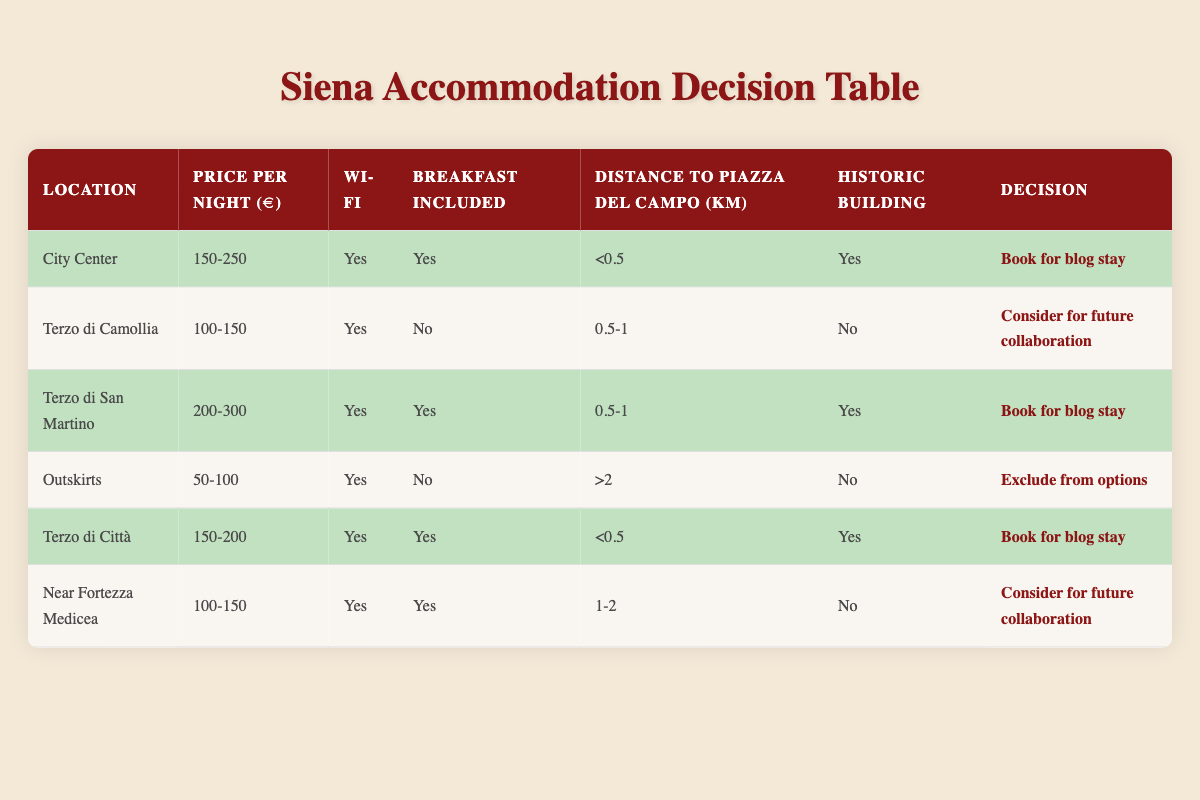What is the price range for accommodations in the City Center? The table shows the price per night for accommodations in the City Center is listed as 150-250 euros.
Answer: 150-250 euros How many accommodation options include breakfast? In the table, the options that include breakfast are the City Center, Terzo di San Martino, Terzo di Città, and Near Fortezza Medicea. There are 4 such accommodations.
Answer: 4 Which location has the highest price per night? The location with the highest price per night is Terzo di San Martino, with a price range of 200-300 euros.
Answer: Terzo di San Martino Is there any accommodation option that is both historic and located at a distance greater than 1 km from Piazza del Campo? The table lists "Outskirts", which is not a historic building and has a distance greater than 2 km. No accommodation meets both criteria of being historic and over 1 km.
Answer: No What is the average distance to Piazza del Campo for accommodations that include Wi-Fi? The distances for accommodations with Wi-Fi are: less than 0.5 km (City Center), 0.5-1 km (Terzo di Camollia, Terzo di San Martino, Near Fortezza Medicea), and greater than 2 km (Outskirts). To calculate the average, convert ranges to approximate values: 0.25 km (City Center), 0.75 km (average of 0.5-1 km), and 2 km (Outskirts). The total is 0.25 + 0.75 + 0.75 + 0.25 + 2 = 4.0 km for 5 accommodations, so the average is 4.0/5 = 0.80 km.
Answer: 0.80 km What is the decision for the location Near Fortezza Medicea? The table indicates that the decision for Near Fortezza Medicea, with the specified conditions, is to "Consider for future collaboration."
Answer: Consider for future collaboration 